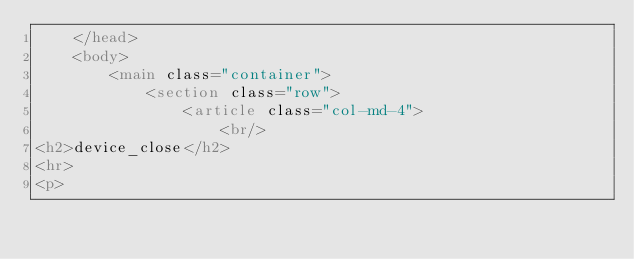Convert code to text. <code><loc_0><loc_0><loc_500><loc_500><_HTML_>    </head>
    <body>
        <main class="container">
            <section class="row">
                <article class="col-md-4">
                    <br/>
<h2>device_close</h2>
<hr>
<p></code> 